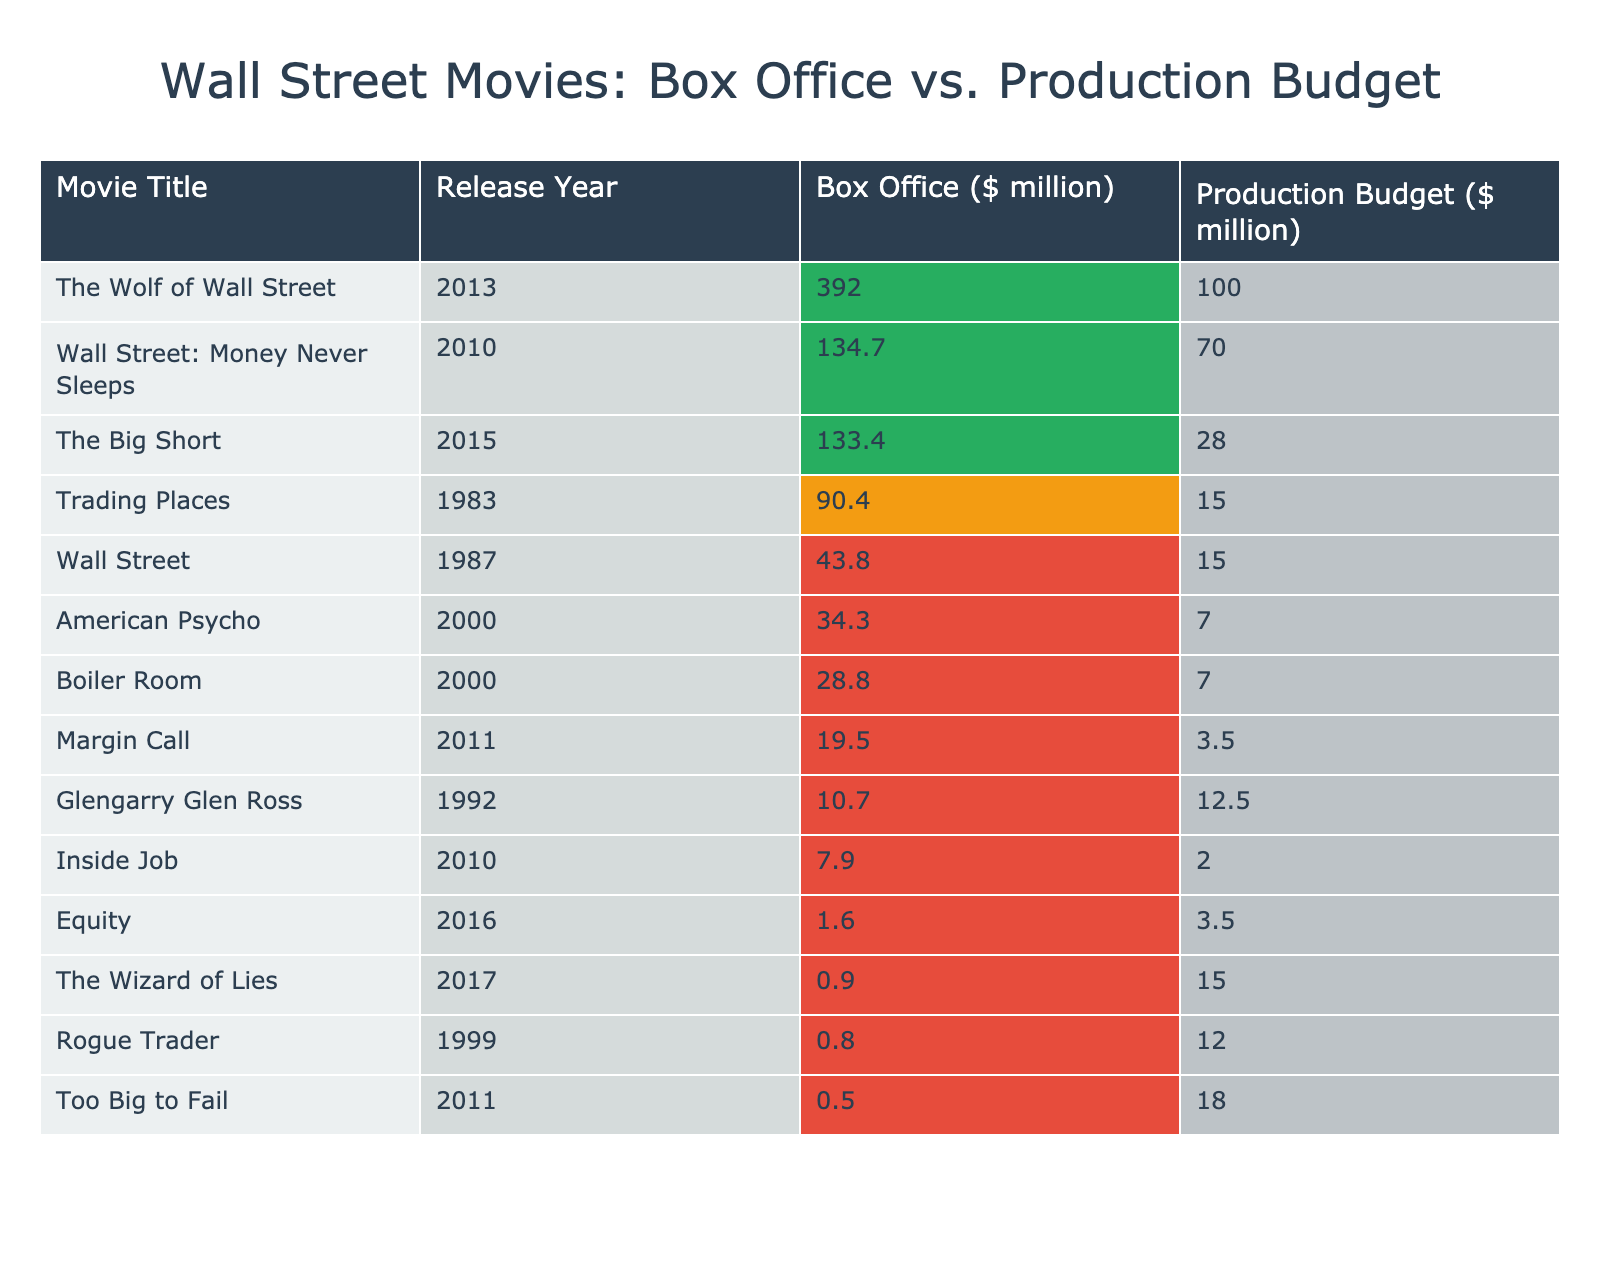What is the box office gross for "The Wolf of Wall Street"? The box office gross for "The Wolf of Wall Street" is listed in the table under Box Office, which shows a value of 392.0 million.
Answer: 392.0 million Which movie had the highest production budget? The table shows the production budgets, and by comparing the values, we see "The Wolf of Wall Street" has the highest production budget of 100 million.
Answer: 100 million What is the average box office gross of all the movies listed? To find the average, we sum the box office gross of all movies: (43.8 + 28.8 + 392 + 19.5 + 133.4 + 134.7 + 90.4 + 0.8 + 34.3 + 0.9 + 0.5 + 7.9 + 1.6 + 10.7) =  844.0 million. Then we divide by 14 (the number of movies) to get 844.0/14 = 60.29 million.
Answer: 60.29 million Which movie had the lowest box office gross? The lowest box office gross can be found by checking the values in the box office column, where "Rogue Trader" has the lowest at 0.8 million.
Answer: 0.8 million Is the production budget for "Inside Job" more than the box office gross for "Equity"? Comparing the production budget for "Inside Job" (2 million) with the box office gross for "Equity" (1.6 million), we see that 2 million is greater than 1.6 million, meaning the statement is true.
Answer: Yes What is the difference in box office performance between "The Big Short" and "Too Big to Fail"? We can find this difference by subtracting the box office gross of "Too Big to Fail" (0.5 million) from that of "The Big Short" (133.4 million): 133.4 - 0.5 = 132.9 million.
Answer: 132.9 million How many movies grossed more than their production budget? By checking each movie in the table, we find that 9 out of the 14 movies have box office gross values higher than their production budgets.
Answer: 9 What is the median production budget of the movies listed? To find the median, we list the production budgets in ascending order: [2, 3.5, 7, 7, 12, 12.5, 15, 15, 18, 28, 70, 100]. The median is the average of the 7th and 8th values, which are 15 and 15, so (15+15)/2 = 15.
Answer: 15 How many movies were released after 2010? By counting the release years in the table, we see that the movies "The Wolf of Wall Street," "Margin Call," "Wall Street: Money Never Sleeps," "The Big Short," "Inside Job," "Equity," and "The Wizard of Lies" were released after 2010, totaling 7 movies.
Answer: 7 Which year had the highest average box office gross for movies released? Calculating the average for movies released in each year listed, we find that 2013 had the highest average due to the high gross of "The Wolf of Wall Street" (392 million), resulting in an average significantly higher than others.
Answer: 2013 